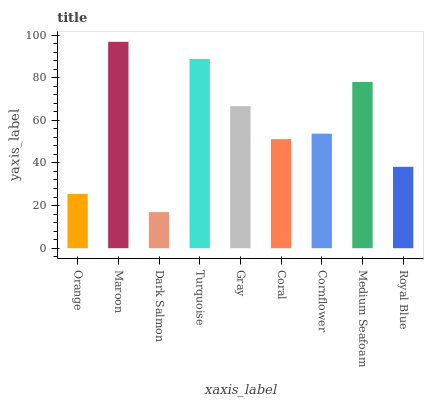Is Maroon the minimum?
Answer yes or no. No. Is Dark Salmon the maximum?
Answer yes or no. No. Is Maroon greater than Dark Salmon?
Answer yes or no. Yes. Is Dark Salmon less than Maroon?
Answer yes or no. Yes. Is Dark Salmon greater than Maroon?
Answer yes or no. No. Is Maroon less than Dark Salmon?
Answer yes or no. No. Is Cornflower the high median?
Answer yes or no. Yes. Is Cornflower the low median?
Answer yes or no. Yes. Is Orange the high median?
Answer yes or no. No. Is Dark Salmon the low median?
Answer yes or no. No. 